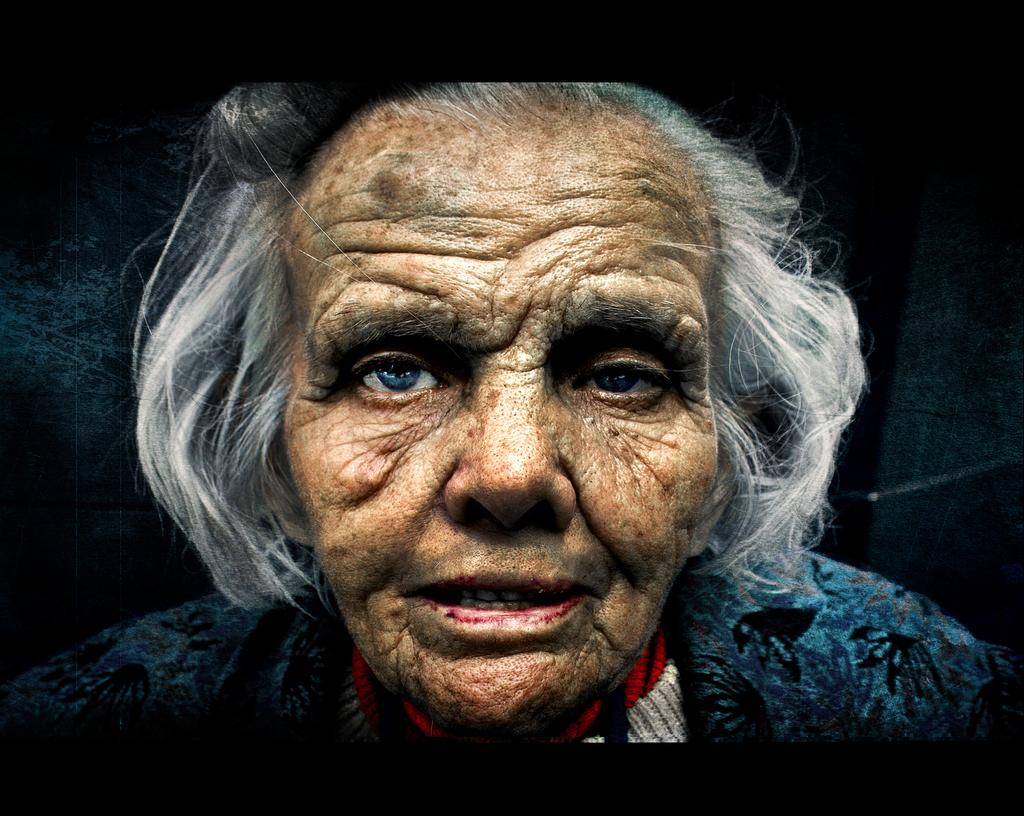Who or what is the main subject in the image? There is a person in the image. Can you describe the person's attire? The person is wearing a blue, red, and white dress. What is the color of the background in the image? The background of the image is black. What type of trains can be seen in the image? There are no trains present in the image. 